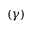<formula> <loc_0><loc_0><loc_500><loc_500>( \gamma )</formula> 